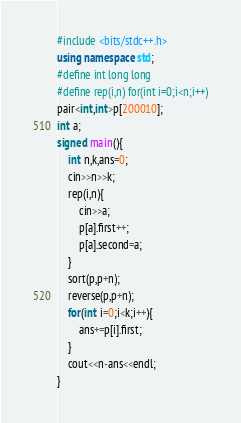<code> <loc_0><loc_0><loc_500><loc_500><_C++_>#include <bits/stdc++.h>
using namespace std;
#define int long long
#define rep(i,n) for(int i=0;i<n;i++)
pair<int,int>p[200010];
int a;
signed main(){
	int n,k,ans=0;
	cin>>n>>k;
	rep(i,n){
		cin>>a;
		p[a].first++;
		p[a].second=a;
	}
	sort(p,p+n);
	reverse(p,p+n);
	for(int i=0;i<k;i++){
		ans+=p[i].first;
	}
	cout<<n-ans<<endl;
}</code> 